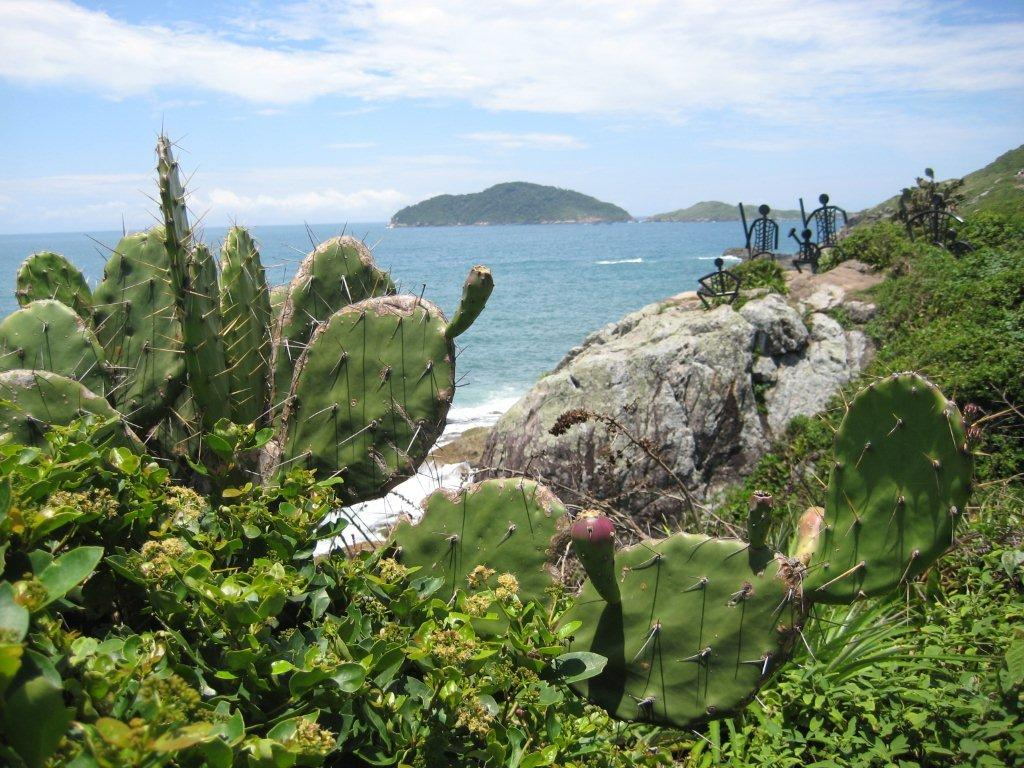What types of living organisms can be seen in the image? Plants can be seen in the image. What type of artwork is present in the image? There are sculptures in the image. What type of ground surface is visible in the image? Grass is visible in the image. What natural element is present in the image? There is a rock in the image. What is the liquid substance visible in the image? There is water in the image. What can be seen in the distance in the image? Hills are visible in the background of the image. What is visible above the hills in the image? Sky is visible in the background of the image. What atmospheric feature can be seen in the sky? Clouds are present in the sky. What type of plastic material is being used to construct the base of the sculptures in the image? There is no mention of plastic material being used to construct the sculptures in the image. Is the queen present in the image? There is no mention of a queen or any person in the image. 